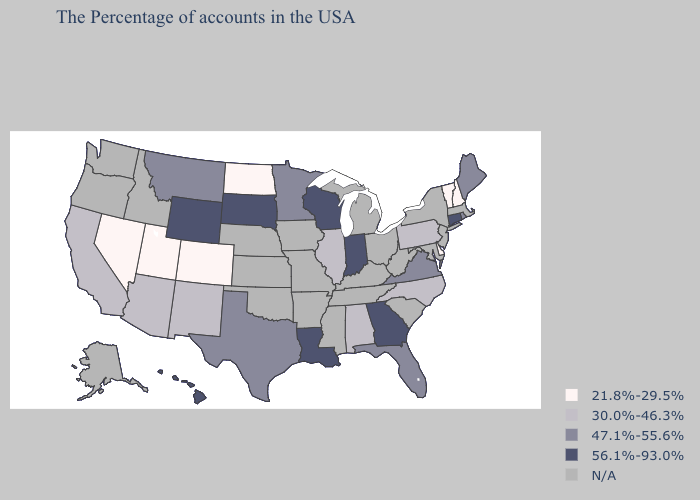What is the lowest value in the West?
Give a very brief answer. 21.8%-29.5%. Does Montana have the highest value in the USA?
Answer briefly. No. What is the value of Maryland?
Concise answer only. N/A. Name the states that have a value in the range 47.1%-55.6%?
Quick response, please. Maine, Rhode Island, Virginia, Florida, Minnesota, Texas, Montana. Which states hav the highest value in the Northeast?
Quick response, please. Connecticut. Does Delaware have the lowest value in the South?
Short answer required. Yes. Name the states that have a value in the range 56.1%-93.0%?
Short answer required. Connecticut, Georgia, Indiana, Wisconsin, Louisiana, South Dakota, Wyoming, Hawaii. What is the value of Arkansas?
Give a very brief answer. N/A. What is the value of Kansas?
Write a very short answer. N/A. What is the lowest value in states that border Ohio?
Give a very brief answer. 30.0%-46.3%. Name the states that have a value in the range 30.0%-46.3%?
Concise answer only. Pennsylvania, North Carolina, Alabama, Illinois, New Mexico, Arizona, California. Name the states that have a value in the range 30.0%-46.3%?
Give a very brief answer. Pennsylvania, North Carolina, Alabama, Illinois, New Mexico, Arizona, California. 